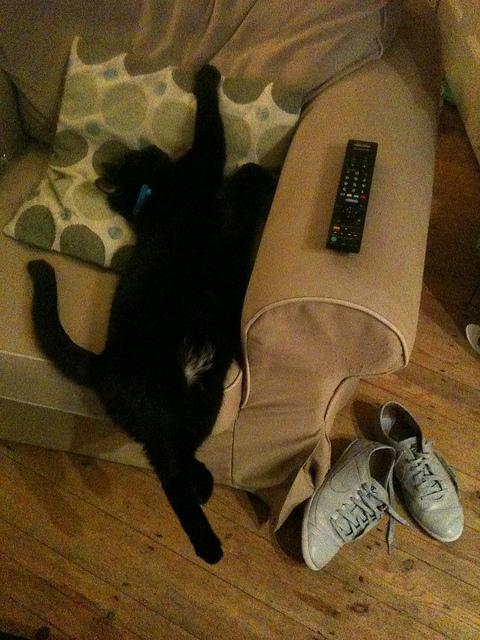What brand are the shoes on the ground? nike 